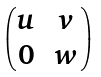Convert formula to latex. <formula><loc_0><loc_0><loc_500><loc_500>\begin{pmatrix} u & v \\ 0 & w \end{pmatrix}</formula> 